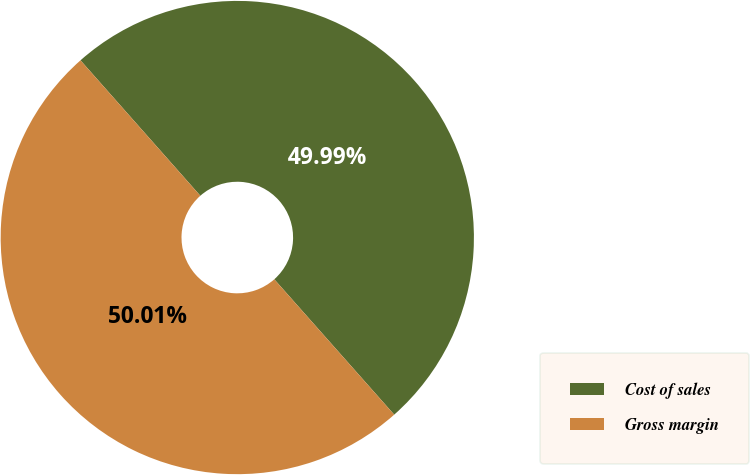Convert chart. <chart><loc_0><loc_0><loc_500><loc_500><pie_chart><fcel>Cost of sales<fcel>Gross margin<nl><fcel>49.99%<fcel>50.01%<nl></chart> 